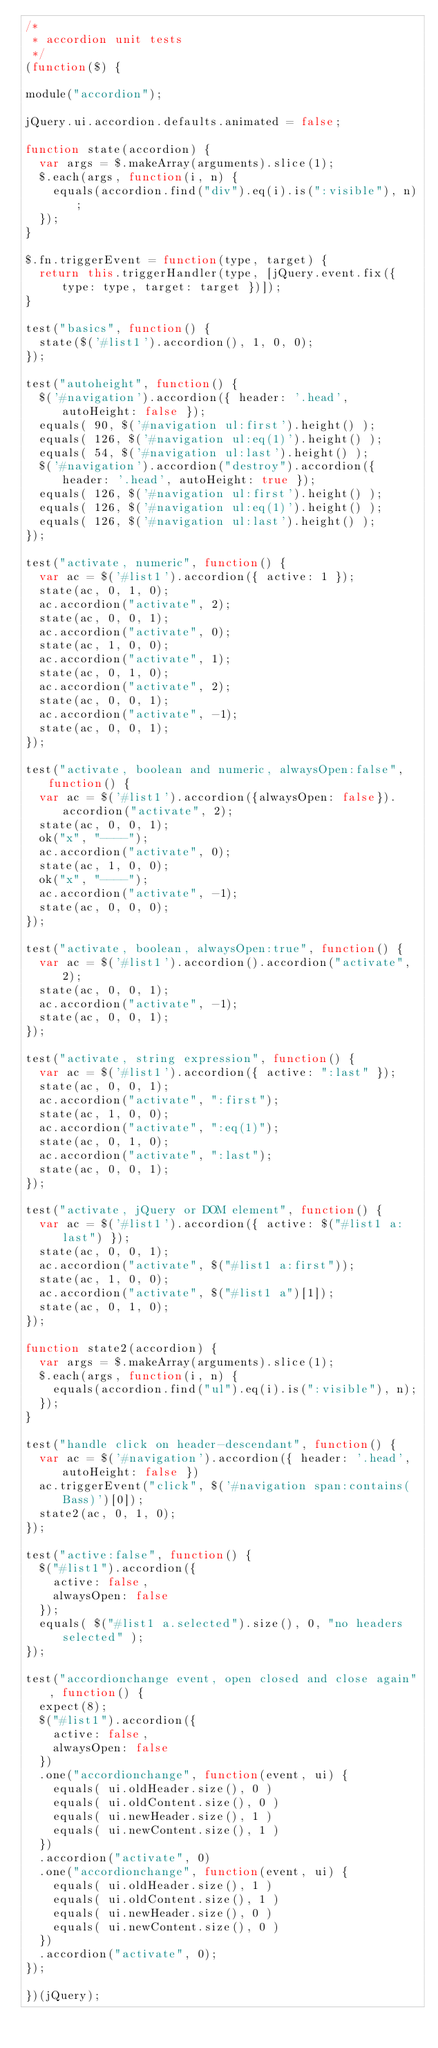Convert code to text. <code><loc_0><loc_0><loc_500><loc_500><_JavaScript_>/*
 * accordion unit tests
 */
(function($) {

module("accordion");

jQuery.ui.accordion.defaults.animated = false;

function state(accordion) {
	var args = $.makeArray(arguments).slice(1);
	$.each(args, function(i, n) {
		equals(accordion.find("div").eq(i).is(":visible"), n);
	});
}

$.fn.triggerEvent = function(type, target) {
	return this.triggerHandler(type, [jQuery.event.fix({ type: type, target: target })]);
}

test("basics", function() {
	state($('#list1').accordion(), 1, 0, 0);
});

test("autoheight", function() {
	$('#navigation').accordion({ header: '.head', autoHeight: false });
	equals( 90, $('#navigation ul:first').height() );
	equals( 126, $('#navigation ul:eq(1)').height() );
	equals( 54, $('#navigation ul:last').height() );
	$('#navigation').accordion("destroy").accordion({ header: '.head', autoHeight: true });
	equals( 126, $('#navigation ul:first').height() );
	equals( 126, $('#navigation ul:eq(1)').height() );
	equals( 126, $('#navigation ul:last').height() );
});

test("activate, numeric", function() {
	var ac = $('#list1').accordion({ active: 1 });
	state(ac, 0, 1, 0);
	ac.accordion("activate", 2);
	state(ac, 0, 0, 1);
	ac.accordion("activate", 0);
	state(ac, 1, 0, 0);
	ac.accordion("activate", 1);
	state(ac, 0, 1, 0);
	ac.accordion("activate", 2);
	state(ac, 0, 0, 1);
	ac.accordion("activate", -1);
	state(ac, 0, 0, 1);
});

test("activate, boolean and numeric, alwaysOpen:false", function() {
	var ac = $('#list1').accordion({alwaysOpen: false}).accordion("activate", 2);
	state(ac, 0, 0, 1);
	ok("x", "----");
	ac.accordion("activate", 0);
	state(ac, 1, 0, 0);
	ok("x", "----");
	ac.accordion("activate", -1);
	state(ac, 0, 0, 0);
});

test("activate, boolean, alwaysOpen:true", function() {
	var ac = $('#list1').accordion().accordion("activate", 2);
	state(ac, 0, 0, 1);
	ac.accordion("activate", -1);
	state(ac, 0, 0, 1);
});

test("activate, string expression", function() {
	var ac = $('#list1').accordion({ active: ":last" });
	state(ac, 0, 0, 1);
	ac.accordion("activate", ":first");
	state(ac, 1, 0, 0);
	ac.accordion("activate", ":eq(1)");
	state(ac, 0, 1, 0);
	ac.accordion("activate", ":last");
	state(ac, 0, 0, 1);
});

test("activate, jQuery or DOM element", function() {
	var ac = $('#list1').accordion({ active: $("#list1 a:last") });
	state(ac, 0, 0, 1);
	ac.accordion("activate", $("#list1 a:first"));
	state(ac, 1, 0, 0);
	ac.accordion("activate", $("#list1 a")[1]);
	state(ac, 0, 1, 0);
});

function state2(accordion) {
	var args = $.makeArray(arguments).slice(1);
	$.each(args, function(i, n) {
		equals(accordion.find("ul").eq(i).is(":visible"), n);
	});
}

test("handle click on header-descendant", function() {
	var ac = $('#navigation').accordion({ header: '.head', autoHeight: false })
	ac.triggerEvent("click", $('#navigation span:contains(Bass)')[0]);
	state2(ac, 0, 1, 0);
});

test("active:false", function() {
	$("#list1").accordion({
		active: false,
		alwaysOpen: false
	});
	equals( $("#list1 a.selected").size(), 0, "no headers selected" );
});

test("accordionchange event, open closed and close again", function() {
	expect(8);
	$("#list1").accordion({
		active: false,
		alwaysOpen: false
	})
	.one("accordionchange", function(event, ui) {
		equals( ui.oldHeader.size(), 0 )
		equals( ui.oldContent.size(), 0 )
		equals( ui.newHeader.size(), 1 )
		equals( ui.newContent.size(), 1 )
	})
	.accordion("activate", 0)
	.one("accordionchange", function(event, ui) {
		equals( ui.oldHeader.size(), 1 )
		equals( ui.oldContent.size(), 1 )
		equals( ui.newHeader.size(), 0 )
		equals( ui.newContent.size(), 0 )
	})
	.accordion("activate", 0);
});

})(jQuery);
</code> 